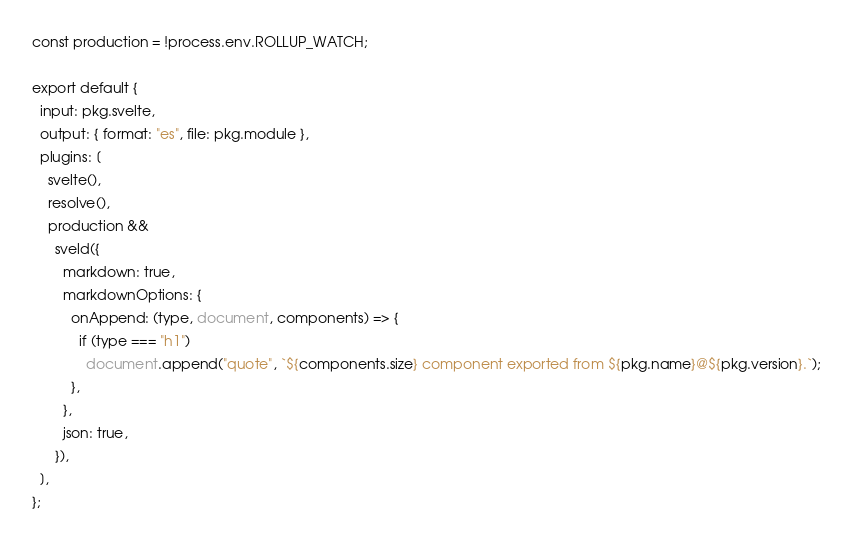Convert code to text. <code><loc_0><loc_0><loc_500><loc_500><_JavaScript_>
const production = !process.env.ROLLUP_WATCH;

export default {
  input: pkg.svelte,
  output: { format: "es", file: pkg.module },
  plugins: [
    svelte(),
    resolve(),
    production &&
      sveld({
        markdown: true,
        markdownOptions: {
          onAppend: (type, document, components) => {
            if (type === "h1")
              document.append("quote", `${components.size} component exported from ${pkg.name}@${pkg.version}.`);
          },
        },
        json: true,
      }),
  ],
};
</code> 